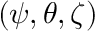<formula> <loc_0><loc_0><loc_500><loc_500>( \psi , \theta , \zeta )</formula> 